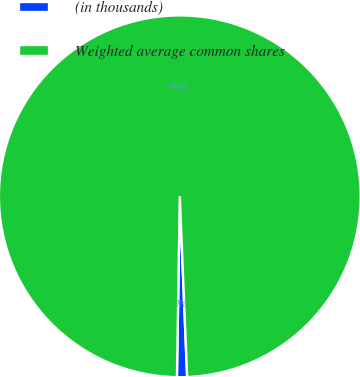Convert chart to OTSL. <chart><loc_0><loc_0><loc_500><loc_500><pie_chart><fcel>(in thousands)<fcel>Weighted average common shares<nl><fcel>0.9%<fcel>99.1%<nl></chart> 